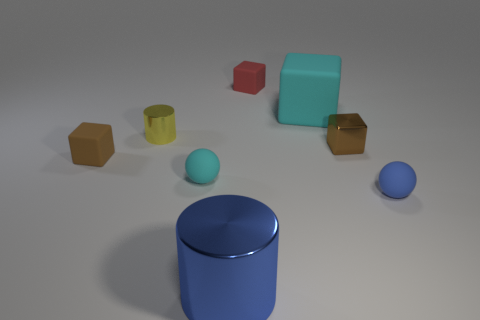Subtract all red blocks. How many blocks are left? 3 Subtract all big rubber cubes. How many cubes are left? 3 Subtract all green blocks. Subtract all blue balls. How many blocks are left? 4 Subtract all spheres. How many objects are left? 6 Add 6 tiny cubes. How many tiny cubes exist? 9 Subtract 1 red blocks. How many objects are left? 7 Subtract all small cyan things. Subtract all red cubes. How many objects are left? 6 Add 4 brown shiny objects. How many brown shiny objects are left? 5 